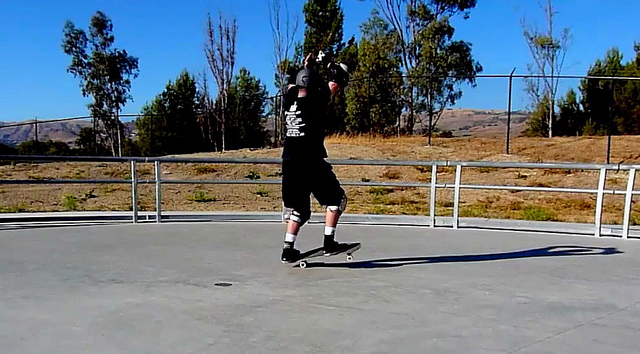What might be the man's motivation for skateboarding in this particular setting? Skateboarding in an open, spacious area like this concrete park offers several advantages that could motivate the man. The flat, smooth surface is ideal for practicing and perfecting tricks without many obstacles. The railings provide opportunities for grind tricks and the open space allows for creativity and flow in movements. Additionally, the park is likely a social hub for skaters, contributing to a sense of community and shared passion. The natural backdrop also provides a visually appealing and serene environment, making the skateboarding experience enjoyable and invigorating. Can you imagine a futuristic skate park? Describe its features. Imagine a futuristic skate park equipped with cutting-edge technology designed to enhance the skating experience. The park features solar-powered surfaces that dynamically adjust to the skater's level, providing varied challenges. LED lights embedded in the concrete change color and pattern to signal different tracks and tricks, creating a vibrant visual spectacle. Advanced sensors and AI systems provide real-time feedback, helping skaters improve their techniques. Holographic obstacles and rails can be projected for customizable and programmable practice sessions. The park also incorporates eco-friendly materials and green spaces, seamlessly blending technology with nature. Additionally, automated medical stations are equipped to provide instant first aid, ensuring skater safety. This futuristic park encourages both individual growth and community engagement, pushing the boundaries of traditional skateboarding experiences. 